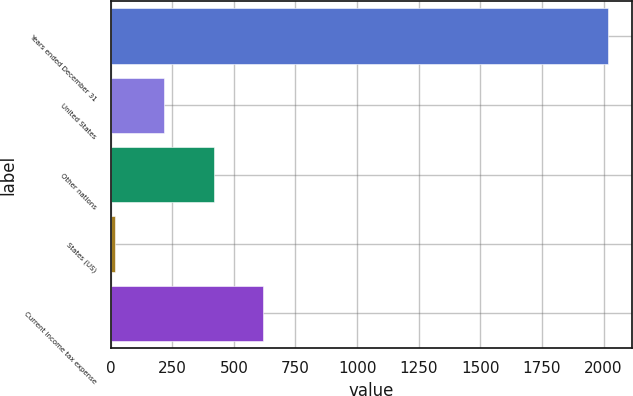Convert chart to OTSL. <chart><loc_0><loc_0><loc_500><loc_500><bar_chart><fcel>Years ended December 31<fcel>United States<fcel>Other nations<fcel>States (US)<fcel>Current income tax expense<nl><fcel>2016<fcel>217.8<fcel>417.6<fcel>18<fcel>617.4<nl></chart> 